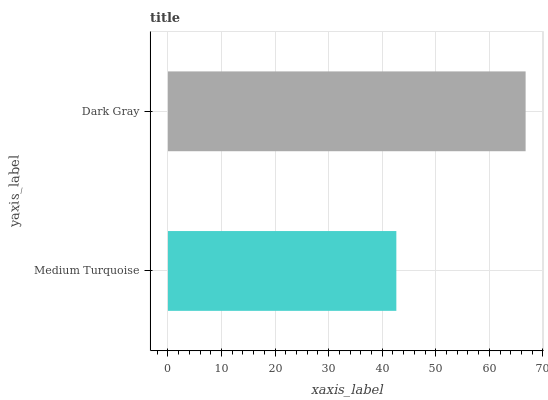Is Medium Turquoise the minimum?
Answer yes or no. Yes. Is Dark Gray the maximum?
Answer yes or no. Yes. Is Dark Gray the minimum?
Answer yes or no. No. Is Dark Gray greater than Medium Turquoise?
Answer yes or no. Yes. Is Medium Turquoise less than Dark Gray?
Answer yes or no. Yes. Is Medium Turquoise greater than Dark Gray?
Answer yes or no. No. Is Dark Gray less than Medium Turquoise?
Answer yes or no. No. Is Dark Gray the high median?
Answer yes or no. Yes. Is Medium Turquoise the low median?
Answer yes or no. Yes. Is Medium Turquoise the high median?
Answer yes or no. No. Is Dark Gray the low median?
Answer yes or no. No. 